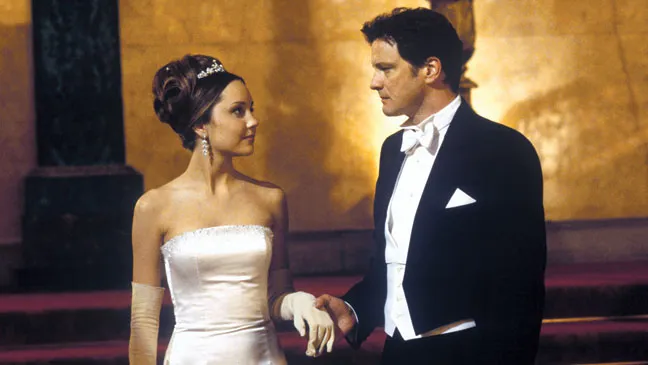What could be the significance of the gold-colored wall in the background? The gold-colored wall in the background could symbolize wealth, grandeur, and opulence, setting the tone for the importance of the event. Gold is often associated with luxury and high status, which aligns with the formal attire of the characters and the evident sophistication of the setting. It serves to underscore the idea that the event they are attending is significant, possibly a high-society gathering or a critical moment in their lives. Can you create a fictional backstory event featuring these characters in the sharegpt4v/same setting? Imagine that the event they are attending is a grand charity gala hosted in a majestic castle. Colin Firth's character, who is a respected diplomat, is due to make a speech that could influence important political alliances. Amanda Bynes’ character is an aspiring artist whose paintings are the highlight of the charity auction. Their paths have crossed at various pivotal moments in their lives, and there's an unspoken chemistry between them, yet societal norms and personal obligations have always kept them apart. As they share a quiet, meaningful glance amidst the grandeur of the evening, they are silently acknowledging their feelings, aware that this might be the last opportunity to express what they've been holding back for years. 